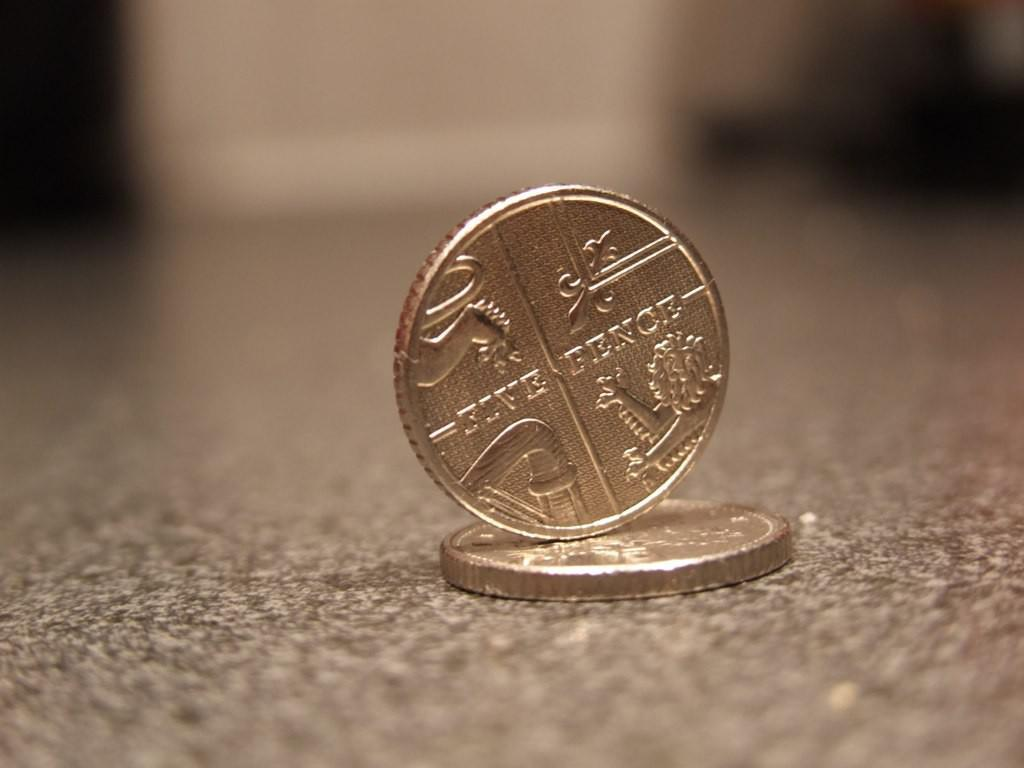<image>
Describe the image concisely. One five pence coin stands upright on top of another coin laying flat on the surface. 